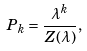Convert formula to latex. <formula><loc_0><loc_0><loc_500><loc_500>P _ { k } = \frac { \lambda ^ { k } } { Z ( \lambda ) } ,</formula> 